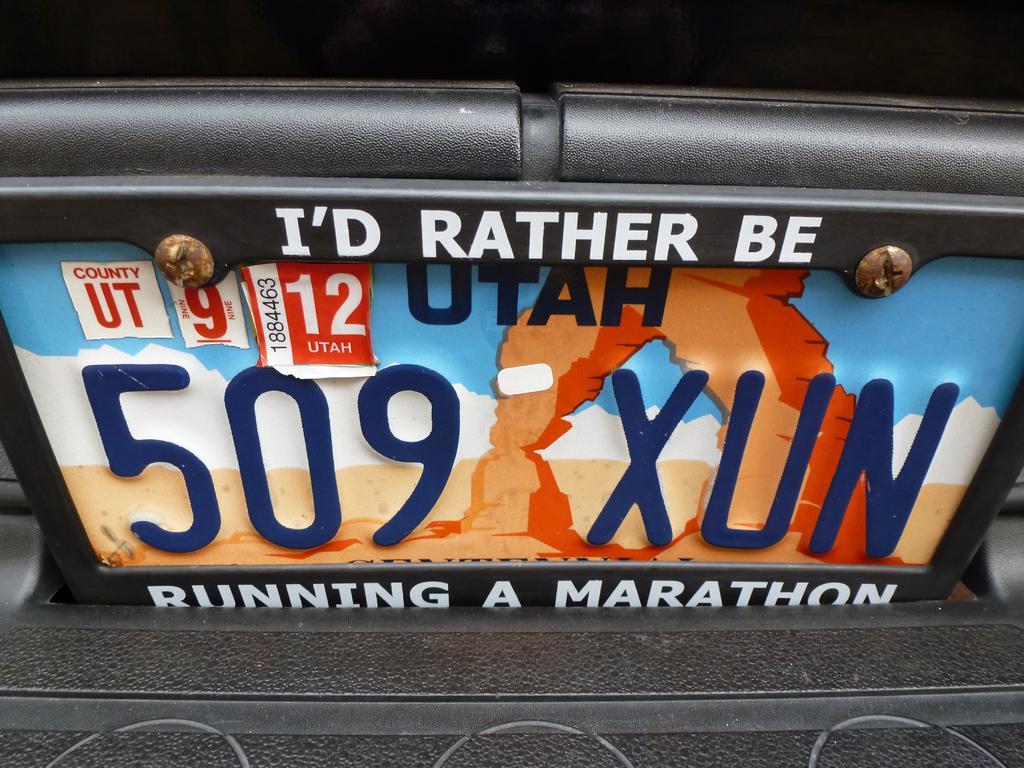<image>
Share a concise interpretation of the image provided. A license plate with a vanity holder displaying the words "I'd rather be running a marathon." 